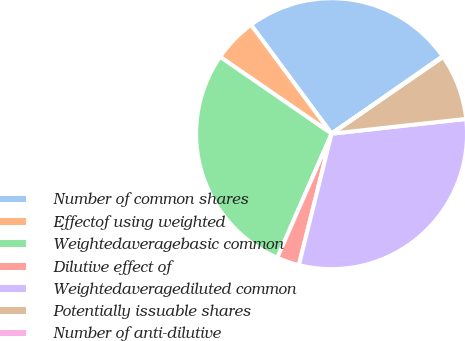Convert chart. <chart><loc_0><loc_0><loc_500><loc_500><pie_chart><fcel>Number of common shares<fcel>Effectof using weighted<fcel>Weightedaveragebasic common<fcel>Dilutive effect of<fcel>Weightedaveragediluted common<fcel>Potentially issuable shares<fcel>Number of anti-dilutive<nl><fcel>25.46%<fcel>5.26%<fcel>28.04%<fcel>2.68%<fcel>30.63%<fcel>7.85%<fcel>0.09%<nl></chart> 